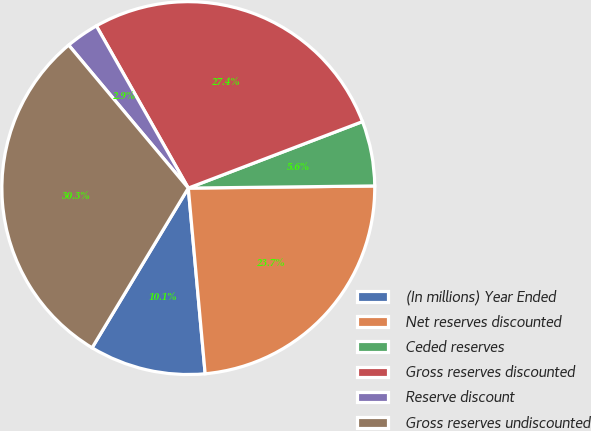Convert chart to OTSL. <chart><loc_0><loc_0><loc_500><loc_500><pie_chart><fcel>(In millions) Year Ended<fcel>Net reserves discounted<fcel>Ceded reserves<fcel>Gross reserves discounted<fcel>Reserve discount<fcel>Gross reserves undiscounted<nl><fcel>10.07%<fcel>23.74%<fcel>5.62%<fcel>27.4%<fcel>2.88%<fcel>30.28%<nl></chart> 